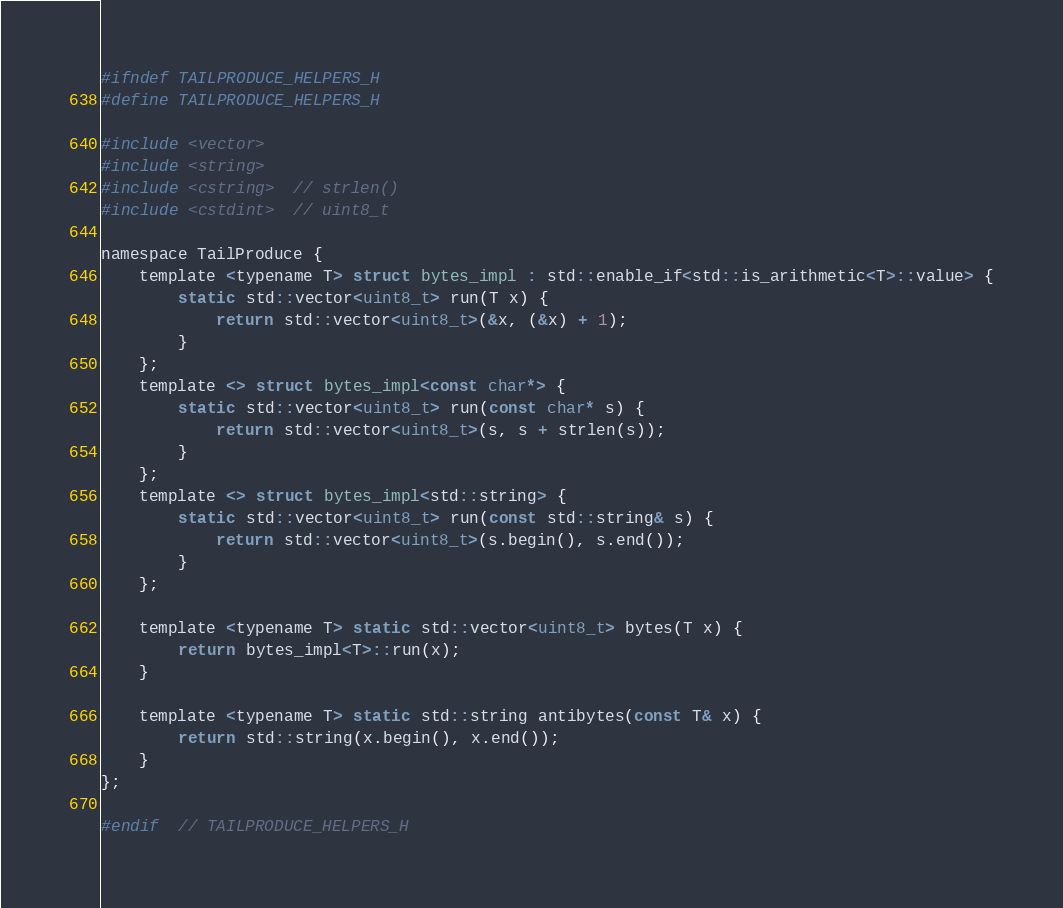<code> <loc_0><loc_0><loc_500><loc_500><_C_>#ifndef TAILPRODUCE_HELPERS_H
#define TAILPRODUCE_HELPERS_H

#include <vector>
#include <string>
#include <cstring>  // strlen()
#include <cstdint>  // uint8_t

namespace TailProduce {
    template <typename T> struct bytes_impl : std::enable_if<std::is_arithmetic<T>::value> {
        static std::vector<uint8_t> run(T x) {
            return std::vector<uint8_t>(&x, (&x) + 1);
        }
    };
    template <> struct bytes_impl<const char*> {
        static std::vector<uint8_t> run(const char* s) {
            return std::vector<uint8_t>(s, s + strlen(s));
        }
    };
    template <> struct bytes_impl<std::string> {
        static std::vector<uint8_t> run(const std::string& s) {
            return std::vector<uint8_t>(s.begin(), s.end());
        }
    };

    template <typename T> static std::vector<uint8_t> bytes(T x) {
        return bytes_impl<T>::run(x);
    }

    template <typename T> static std::string antibytes(const T& x) {
        return std::string(x.begin(), x.end());
    }
};

#endif  // TAILPRODUCE_HELPERS_H
</code> 